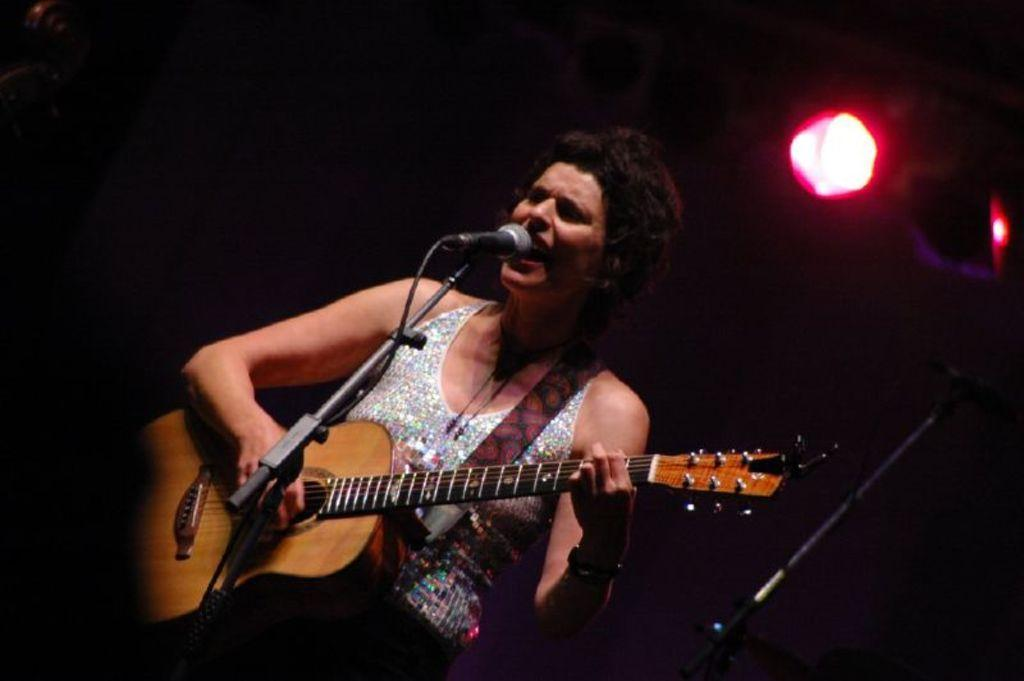What is the woman in the image doing? The woman is singing and playing a guitar in the image. Can you describe the woman's appearance? The woman has short hair. What object is the woman using to amplify her voice? There is a microphone in the image. What can be seen in the background of the image? There is a light in the background of the image. What type of dress is the woman wearing in the image? The provided facts do not mention a dress, so we cannot determine the type of dress the woman is wearing. 